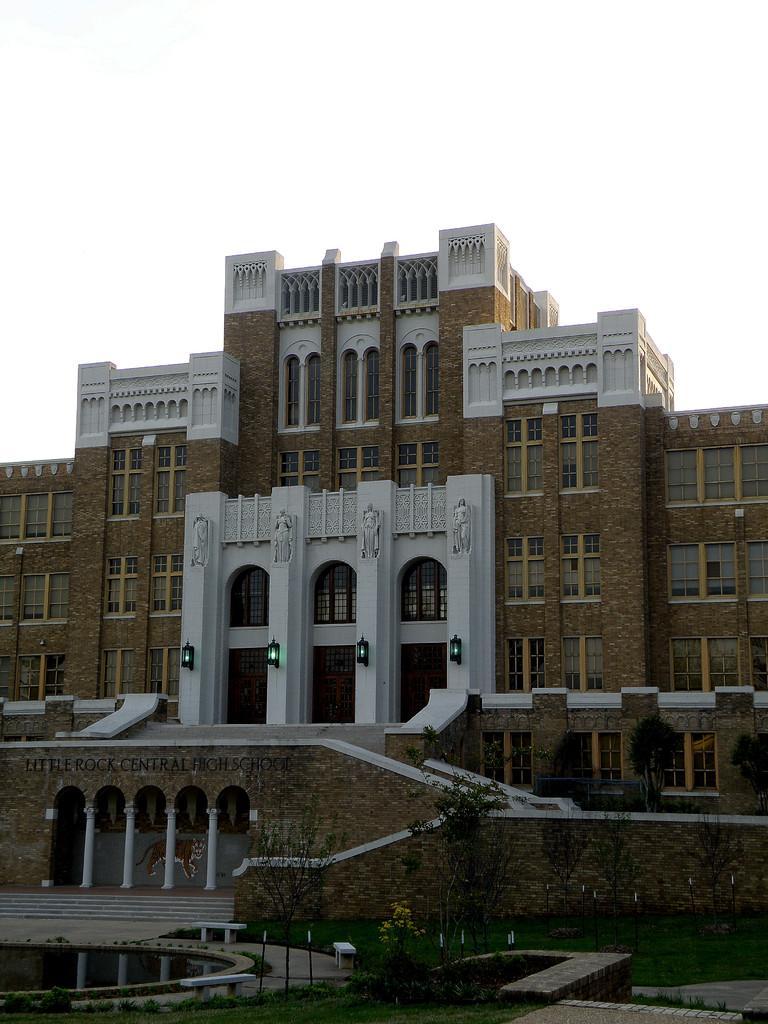Please provide a concise description of this image. In the picture I can see the building and glass windows. I can see the pillars and staircase on the bottom left side. I can see the decorative lights on the wall of the building. It is looking like a water pool on the bottom left side of the picture. There are trees on the right side. 